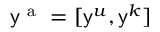Convert formula to latex. <formula><loc_0><loc_0><loc_500><loc_500>y ^ { a } = [ y ^ { u } , y ^ { k } ]</formula> 